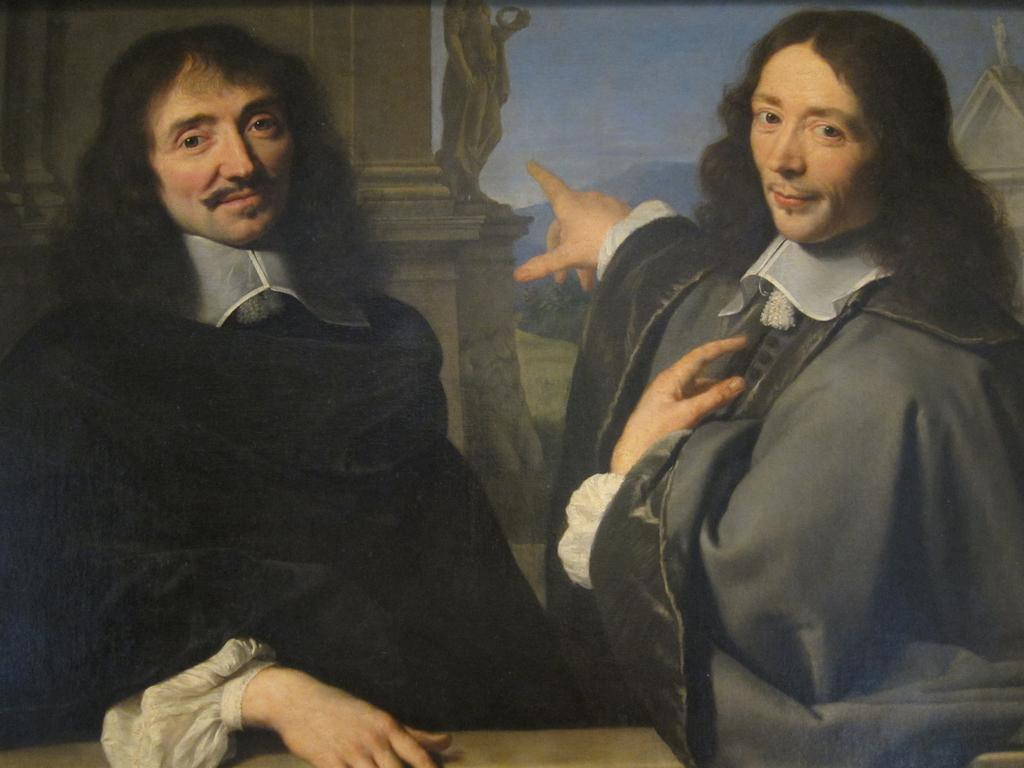What is depicted in the painting in the image? The painting contains a scene with two persons. What can be seen on the wall in the painting? There is a statue on the wall in the painting. What type of vegetation is present in the painting? There are plants in the painting. What geographical feature is visible in the painting? There is a hill in the painting. What type of structure is on the right side of the painting? There is a building on the right side of the painting. What type of roof can be seen on the transport vehicle in the painting? There is no transport vehicle present in the painting; it features a scene with two persons, a statue, plants, a hill, and a building. 